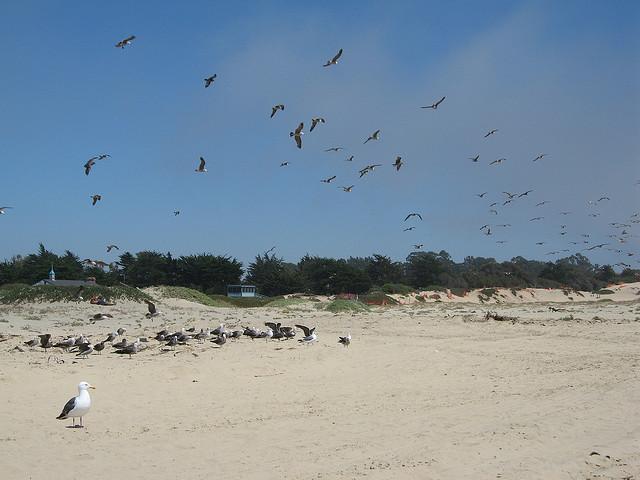What types of animals are in this picture?
Write a very short answer. Birds. How many kites are in the air?
Be succinct. 0. What is in the air?
Answer briefly. Birds. Where is the bird?
Be succinct. Beach. Where was the picture of the birds taken?
Be succinct. Beach. What is in the sky?
Write a very short answer. Birds. Where is the bird landing?
Be succinct. Beach. Is there a bird in the picture?
Give a very brief answer. Yes. Why can we assume this is next to a large body of water?
Answer briefly. Seagulls. How much sand is on the beach?
Keep it brief. Lot. What's in the sky?
Answer briefly. Birds. Is it sunny outside?
Keep it brief. Yes. Are they flying kites?
Short answer required. No. What are the birds doing?
Give a very brief answer. Flying. What is flying in the sky?
Write a very short answer. Birds. How many birds are in the air?
Short answer required. Many. What kind of bird is standing on the beach?
Answer briefly. Seagull. How many birds can be seen in the scene?
Short answer required. Many. Are the birds eating leftovers?
Answer briefly. No. Is it a nice day at the beach?
Write a very short answer. Yes. What is the object in the sky?
Short answer required. Birds. What color is the bird?
Concise answer only. White. Is this a beach?
Write a very short answer. Yes. Are those birds seen in the sky?
Answer briefly. Yes. How many birds flying?
Short answer required. Many. What kind of prints are in the sand?
Short answer required. Foot. How many kites in this picture?
Keep it brief. 0. 